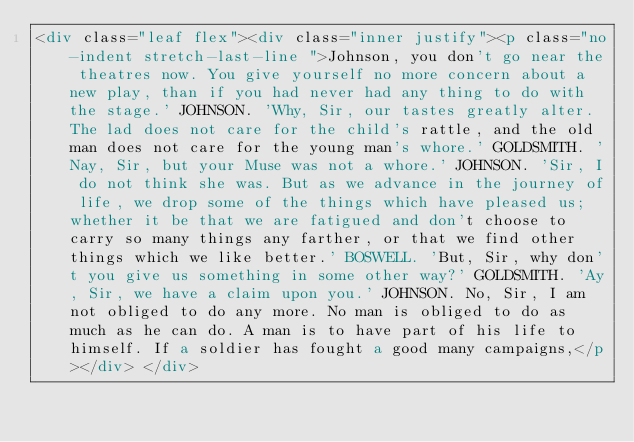<code> <loc_0><loc_0><loc_500><loc_500><_HTML_><div class="leaf flex"><div class="inner justify"><p class="no-indent stretch-last-line ">Johnson, you don't go near the theatres now. You give yourself no more concern about a new play, than if you had never had any thing to do with the stage.' JOHNSON. 'Why, Sir, our tastes greatly alter. The lad does not care for the child's rattle, and the old man does not care for the young man's whore.' GOLDSMITH. 'Nay, Sir, but your Muse was not a whore.' JOHNSON. 'Sir, I do not think she was. But as we advance in the journey of life, we drop some of the things which have pleased us; whether it be that we are fatigued and don't choose to carry so many things any farther, or that we find other things which we like better.' BOSWELL. 'But, Sir, why don't you give us something in some other way?' GOLDSMITH. 'Ay, Sir, we have a claim upon you.' JOHNSON. No, Sir, I am not obliged to do any more. No man is obliged to do as much as he can do. A man is to have part of his life to himself. If a soldier has fought a good many campaigns,</p></div> </div></code> 